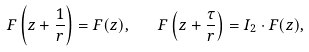Convert formula to latex. <formula><loc_0><loc_0><loc_500><loc_500>F \left ( z + \frac { 1 } { r } \right ) = F ( z ) , \quad F \left ( z + \frac { \tau } r \right ) = I _ { 2 } \cdot F ( z ) ,</formula> 